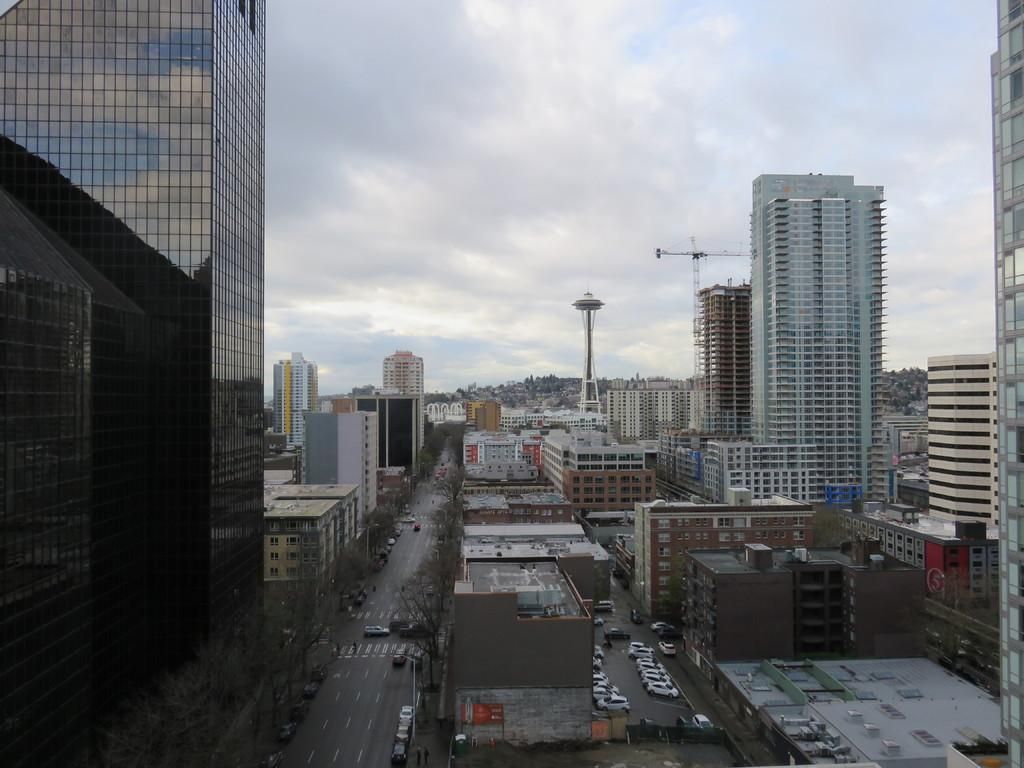What type of structures can be seen in the image? There are buildings in the image. What other natural elements are present in the image? There are trees in the image. What can be seen related to transportation in the image? There are parked cars and moving cars on the road in the image. Are there any tall structures in the image? Yes, there is a tower in the image. What type of construction equipment is visible in the image? There is a crane in the image. How would you describe the sky in the image? The sky is blue and cloudy in the image. What type of powder is being used to clean the doll in the image? There is no doll or powder present in the image. What type of house is visible in the image? There is no house visible in the image; only buildings, trees, cars, a tower, a crane, and the sky are present. 